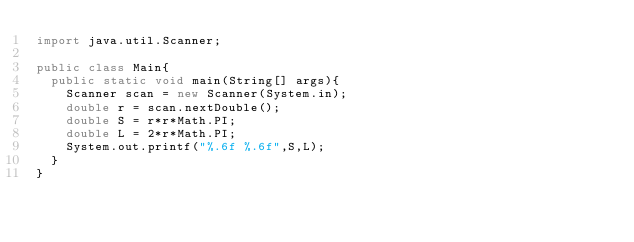<code> <loc_0><loc_0><loc_500><loc_500><_Java_>import java.util.Scanner;

public class Main{
  public static void main(String[] args){
    Scanner scan = new Scanner(System.in);
    double r = scan.nextDouble();
    double S = r*r*Math.PI;
    double L = 2*r*Math.PI;
    System.out.printf("%.6f %.6f",S,L);
  } 
}</code> 